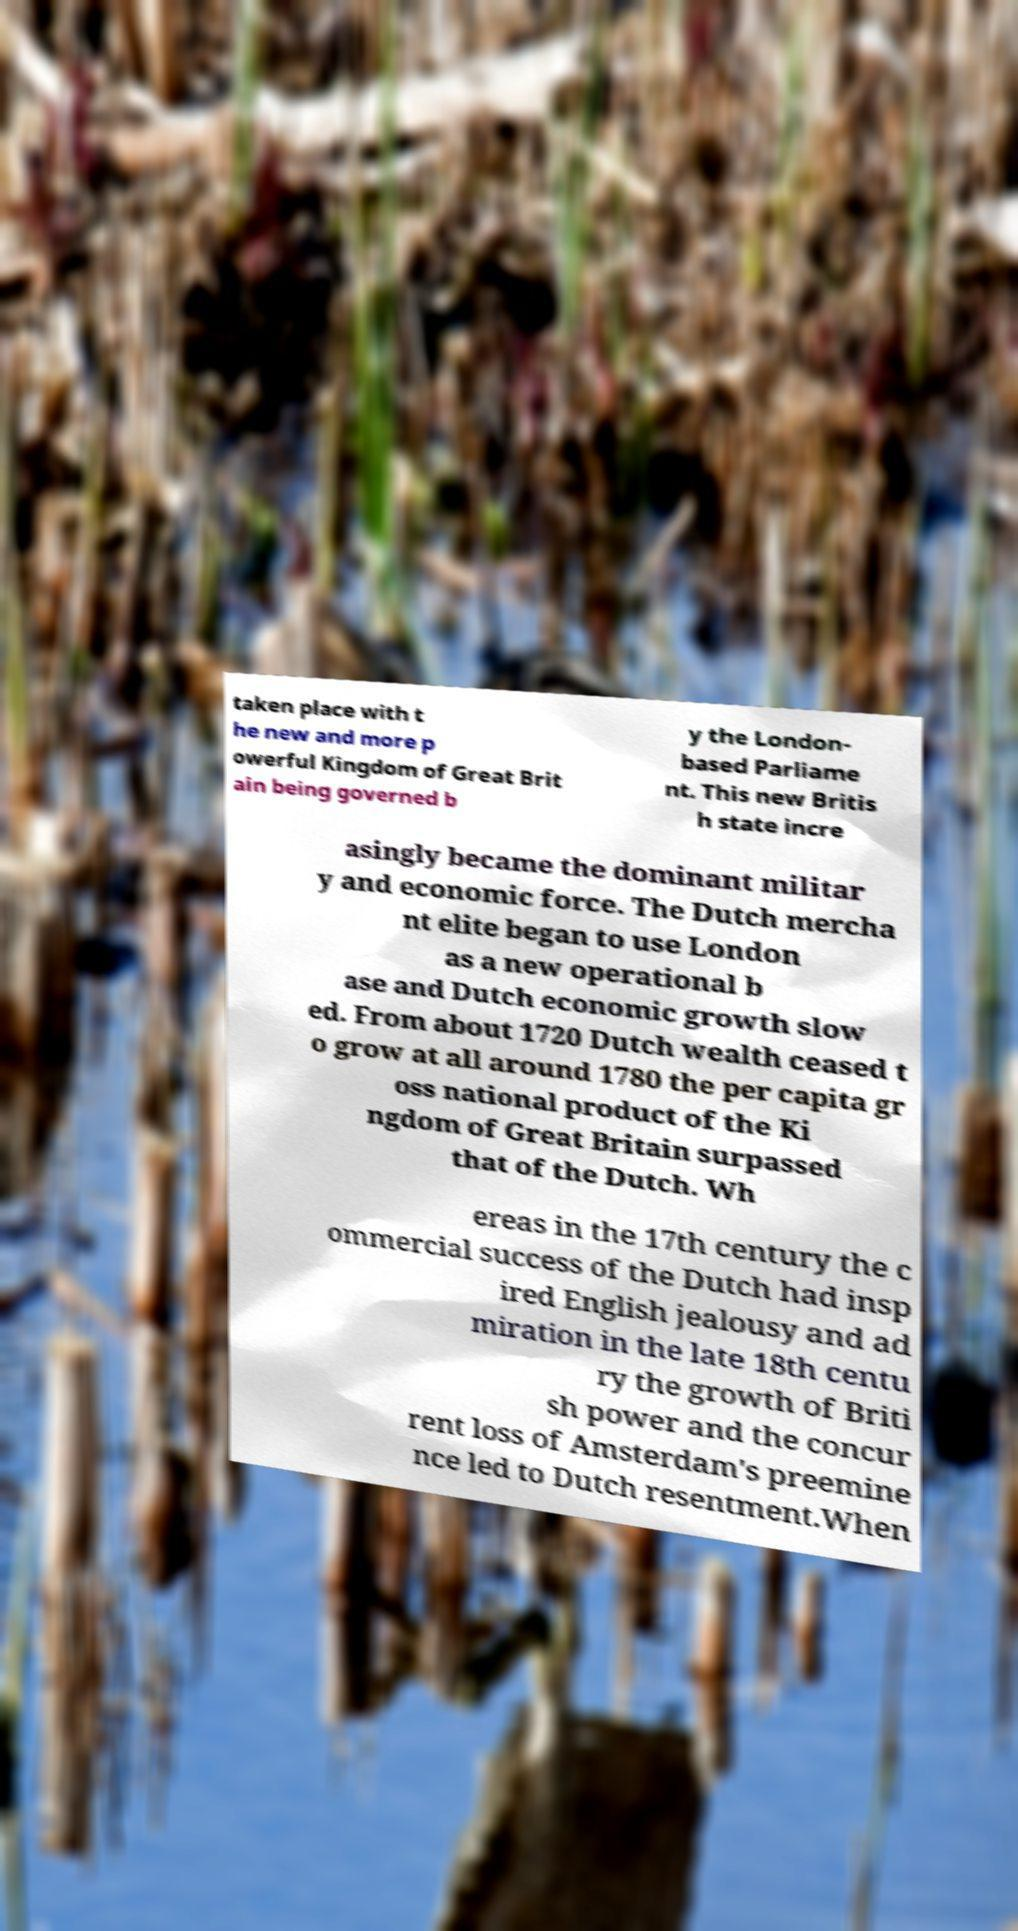Could you assist in decoding the text presented in this image and type it out clearly? taken place with t he new and more p owerful Kingdom of Great Brit ain being governed b y the London- based Parliame nt. This new Britis h state incre asingly became the dominant militar y and economic force. The Dutch mercha nt elite began to use London as a new operational b ase and Dutch economic growth slow ed. From about 1720 Dutch wealth ceased t o grow at all around 1780 the per capita gr oss national product of the Ki ngdom of Great Britain surpassed that of the Dutch. Wh ereas in the 17th century the c ommercial success of the Dutch had insp ired English jealousy and ad miration in the late 18th centu ry the growth of Briti sh power and the concur rent loss of Amsterdam's preemine nce led to Dutch resentment.When 